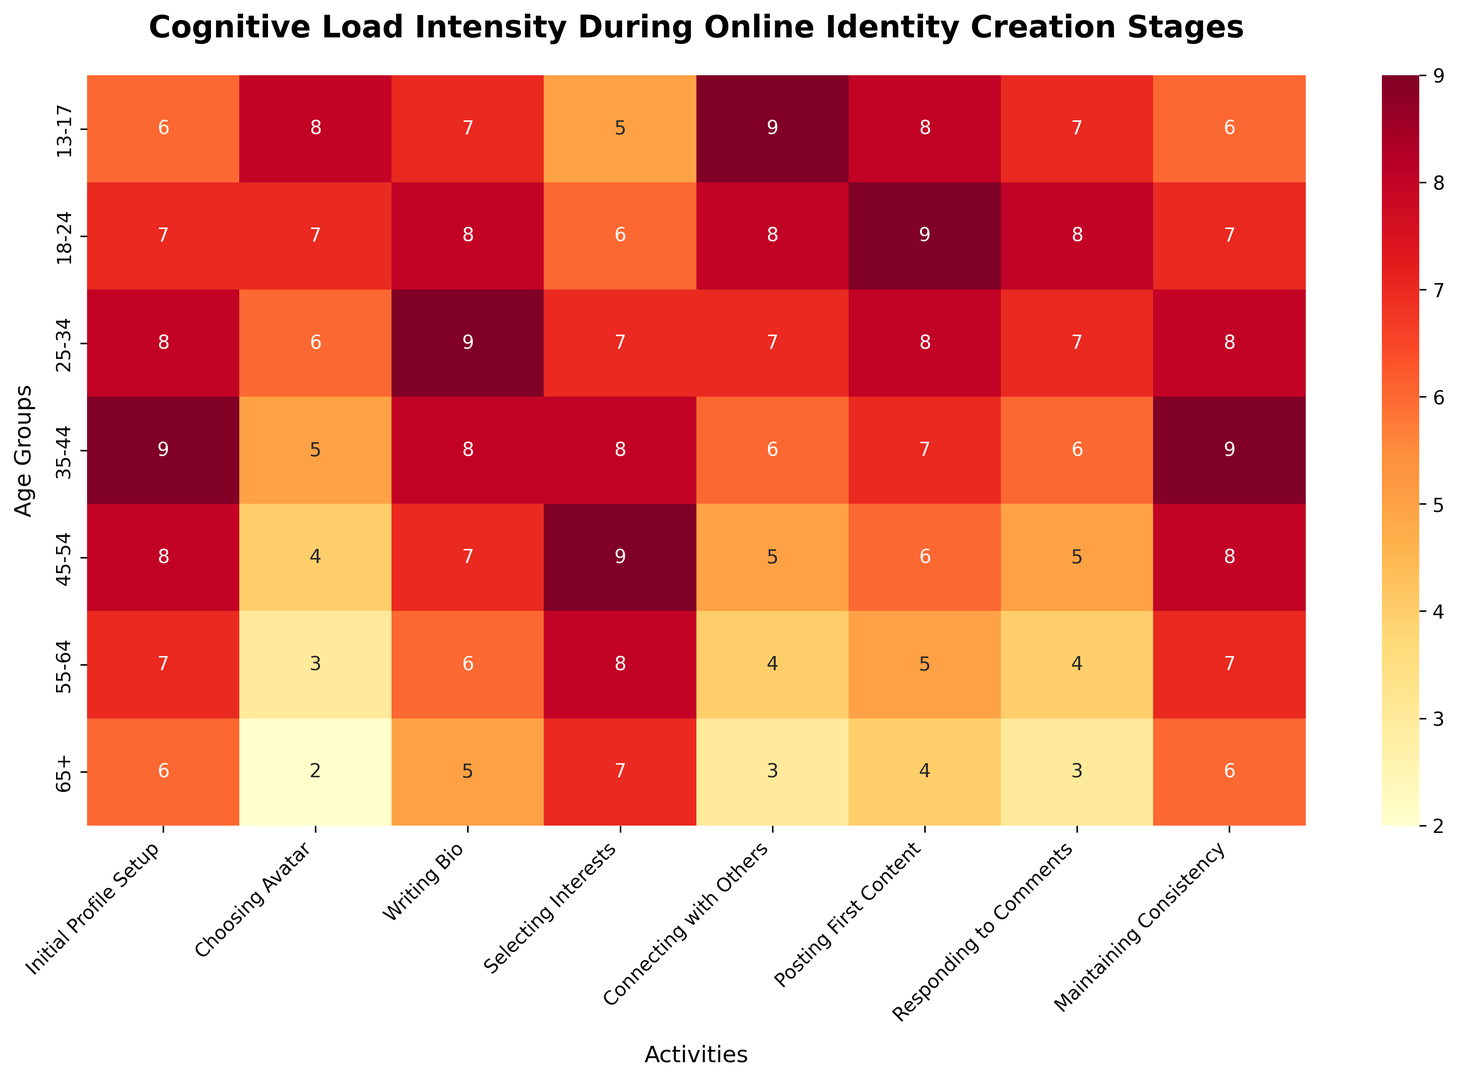What's the highest cognitive load intensity across all age groups for "Choosing Avatar"? First, look at the column labeled "Choosing Avatar," where the values of cognitive load intensities are displayed for each age group. Identify the highest value in that column. The observed highest cognitive load intensity is 8 for the age group 13-17.
Answer: 8 Which age group experiences the least cognitive load during the "Connecting with Others" stage? Examine the "Connecting with Others" column to find the smallest value. The smallest value is 3, which corresponds to the 65+ age group.
Answer: 65+ What's the average cognitive load intensity for the "Writing Bio" stage across all age groups? Add up all the cognitive load intensities for the "Writing Bio" stage (7+8+9+8+7+6+5 = 50) and then divide by the number of age groups (7). The result is 50/7.
Answer: 7.14 During the "Maintaining Consistency" stage, which age group has the highest cognitive load, and what is the value? The "Maintaining Consistency" column shows the cognitive load for each age group. Identify the highest value (9) and the corresponding age group (35-44).
Answer: 35-44, 9 Is the cognitive load for "Posting First Content" higher for age group 13-17 or 25-34? Compare the values in the "Posting First Content" column for age groups 13-17 (8) and 25-34 (8). Both groups have the same cognitive load value.
Answer: Same By how much does the cognitive load intensity for "Selecting Interests" differ between age groups 18-24 and 55-64? Find the values for the "Selecting Interests" stage for age groups 18-24 (6) and 55-64 (8). Subtract the smaller value from the larger one (8 - 6).
Answer: 2 Which stage shows the greatest range of cognitive load intensities across all age groups? Calculate the range for each stage by subtracting the minimum value from the maximum value. For example, for "Connecting with Others": 9-3=6, "Initial Profile Setup": 9-6=3, etc. The stage "Connecting with Others" has the greatest range (6).
Answer: Connecting with Others What's the median cognitive load intensity for the "Responding to Comments" stage? Sort the values in the "Responding to Comments" column (3, 4, 5, 6, 6, 7, 8). Since there are 7 values, the median is the 4th value when sorted: 6.
Answer: 6 